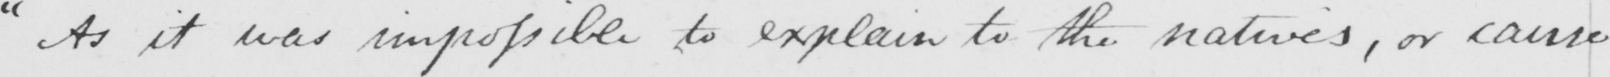Can you read and transcribe this handwriting? " As it was impossible to explain to the natives , or cause 